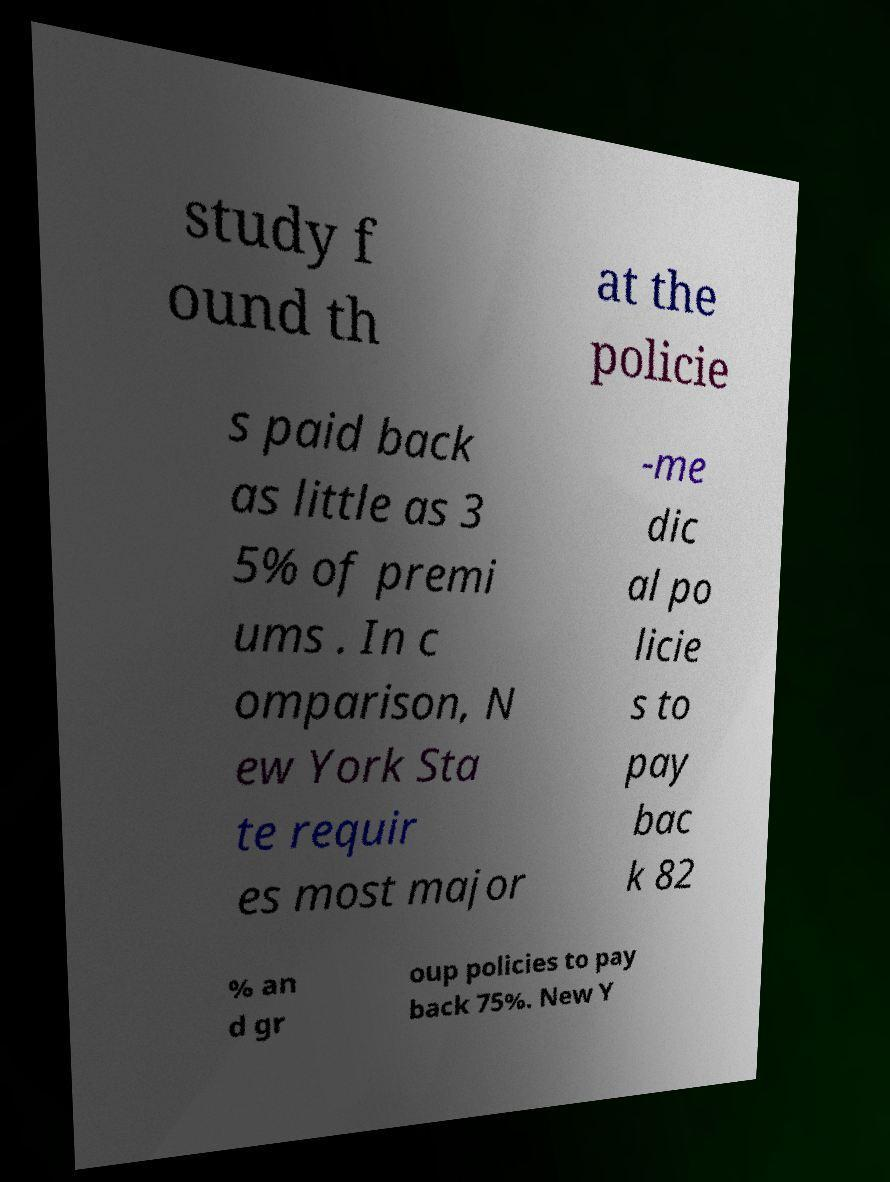Can you read and provide the text displayed in the image?This photo seems to have some interesting text. Can you extract and type it out for me? study f ound th at the policie s paid back as little as 3 5% of premi ums . In c omparison, N ew York Sta te requir es most major -me dic al po licie s to pay bac k 82 % an d gr oup policies to pay back 75%. New Y 